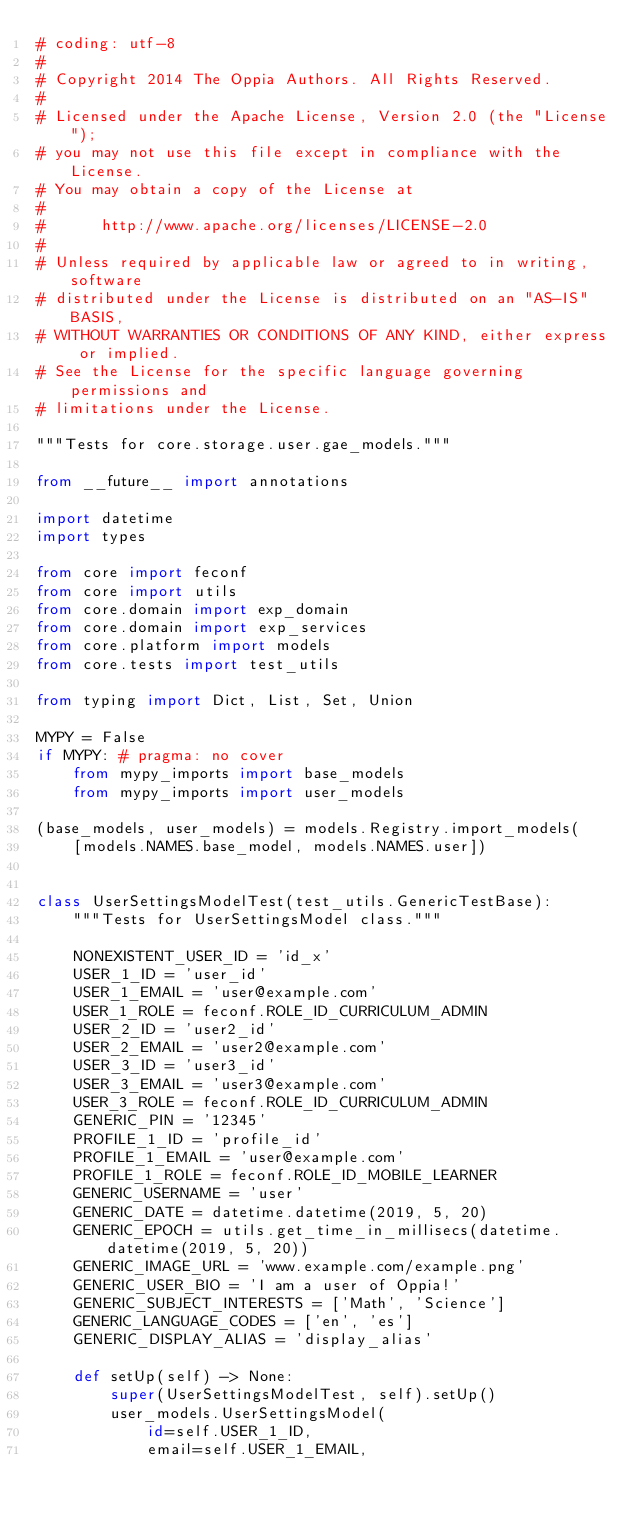<code> <loc_0><loc_0><loc_500><loc_500><_Python_># coding: utf-8
#
# Copyright 2014 The Oppia Authors. All Rights Reserved.
#
# Licensed under the Apache License, Version 2.0 (the "License");
# you may not use this file except in compliance with the License.
# You may obtain a copy of the License at
#
#      http://www.apache.org/licenses/LICENSE-2.0
#
# Unless required by applicable law or agreed to in writing, software
# distributed under the License is distributed on an "AS-IS" BASIS,
# WITHOUT WARRANTIES OR CONDITIONS OF ANY KIND, either express or implied.
# See the License for the specific language governing permissions and
# limitations under the License.

"""Tests for core.storage.user.gae_models."""

from __future__ import annotations

import datetime
import types

from core import feconf
from core import utils
from core.domain import exp_domain
from core.domain import exp_services
from core.platform import models
from core.tests import test_utils

from typing import Dict, List, Set, Union

MYPY = False
if MYPY: # pragma: no cover
    from mypy_imports import base_models
    from mypy_imports import user_models

(base_models, user_models) = models.Registry.import_models(
    [models.NAMES.base_model, models.NAMES.user])


class UserSettingsModelTest(test_utils.GenericTestBase):
    """Tests for UserSettingsModel class."""

    NONEXISTENT_USER_ID = 'id_x'
    USER_1_ID = 'user_id'
    USER_1_EMAIL = 'user@example.com'
    USER_1_ROLE = feconf.ROLE_ID_CURRICULUM_ADMIN
    USER_2_ID = 'user2_id'
    USER_2_EMAIL = 'user2@example.com'
    USER_3_ID = 'user3_id'
    USER_3_EMAIL = 'user3@example.com'
    USER_3_ROLE = feconf.ROLE_ID_CURRICULUM_ADMIN
    GENERIC_PIN = '12345'
    PROFILE_1_ID = 'profile_id'
    PROFILE_1_EMAIL = 'user@example.com'
    PROFILE_1_ROLE = feconf.ROLE_ID_MOBILE_LEARNER
    GENERIC_USERNAME = 'user'
    GENERIC_DATE = datetime.datetime(2019, 5, 20)
    GENERIC_EPOCH = utils.get_time_in_millisecs(datetime.datetime(2019, 5, 20))
    GENERIC_IMAGE_URL = 'www.example.com/example.png'
    GENERIC_USER_BIO = 'I am a user of Oppia!'
    GENERIC_SUBJECT_INTERESTS = ['Math', 'Science']
    GENERIC_LANGUAGE_CODES = ['en', 'es']
    GENERIC_DISPLAY_ALIAS = 'display_alias'

    def setUp(self) -> None:
        super(UserSettingsModelTest, self).setUp()
        user_models.UserSettingsModel(
            id=self.USER_1_ID,
            email=self.USER_1_EMAIL,</code> 